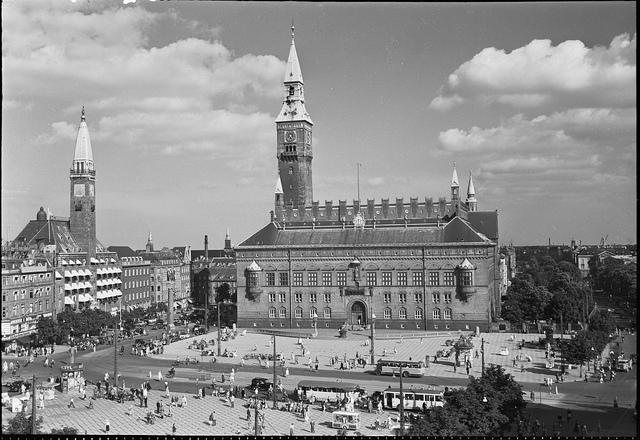Where is the photograph?
Write a very short answer. England. Is the photo colored?
Keep it brief. No. Are these buildings less than 10 years old?
Answer briefly. No. 